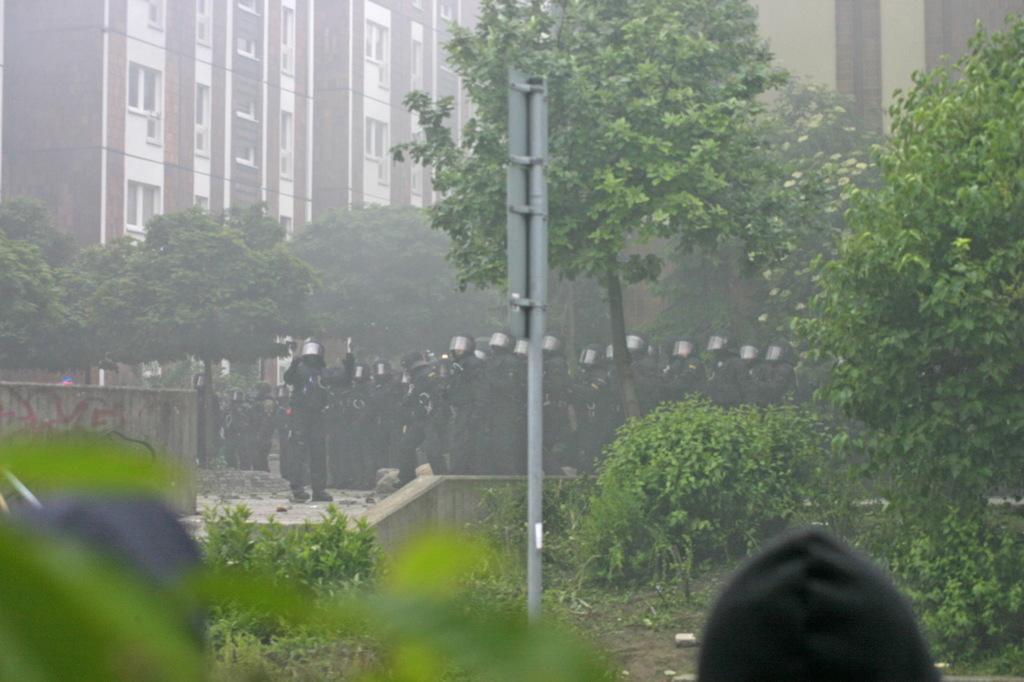Can you describe this image briefly? This picture is clicked outside. In the foreground we can see the plants, pole and some other objects. In the center we can see the group of persons wearing helmets and standing. In the background we can see the trees, buildings and some other objects. 